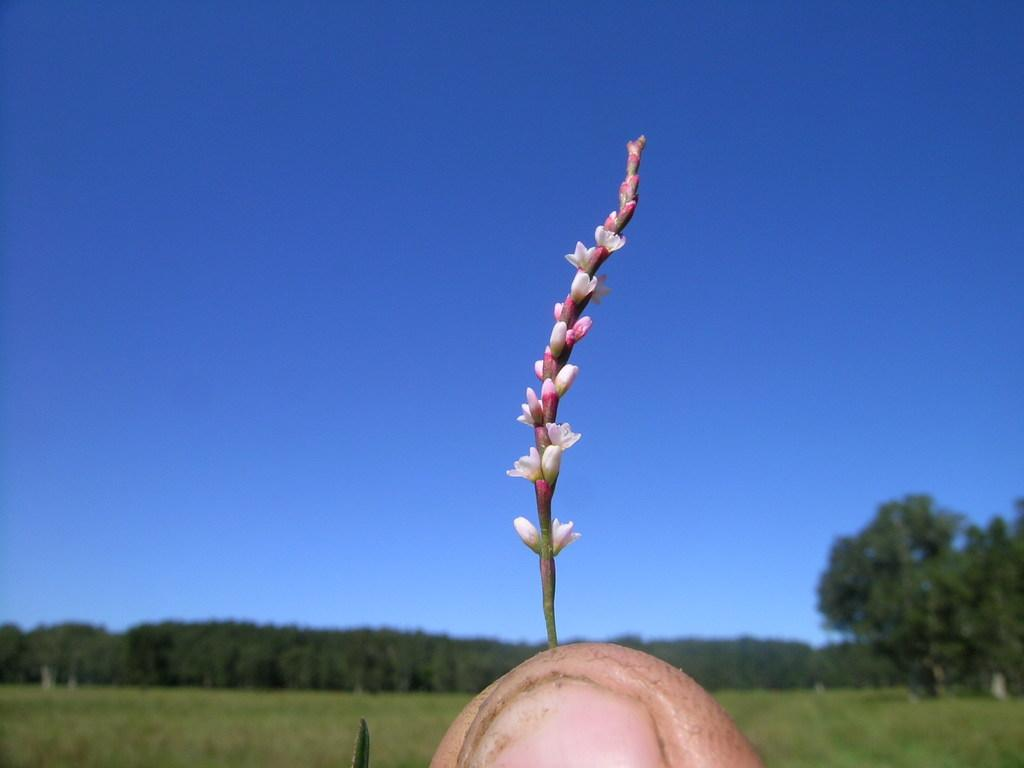What is the main subject of the image? The main subject of the image is a stem with small flowers. What can be seen in the background of the image? There is a group of trees and the sky visible in the background of the image. How much payment is required to access the stone on the edge in the image? There is no stone or edge present in the image; it only features a stem with small flowers and a background with trees and the sky. 